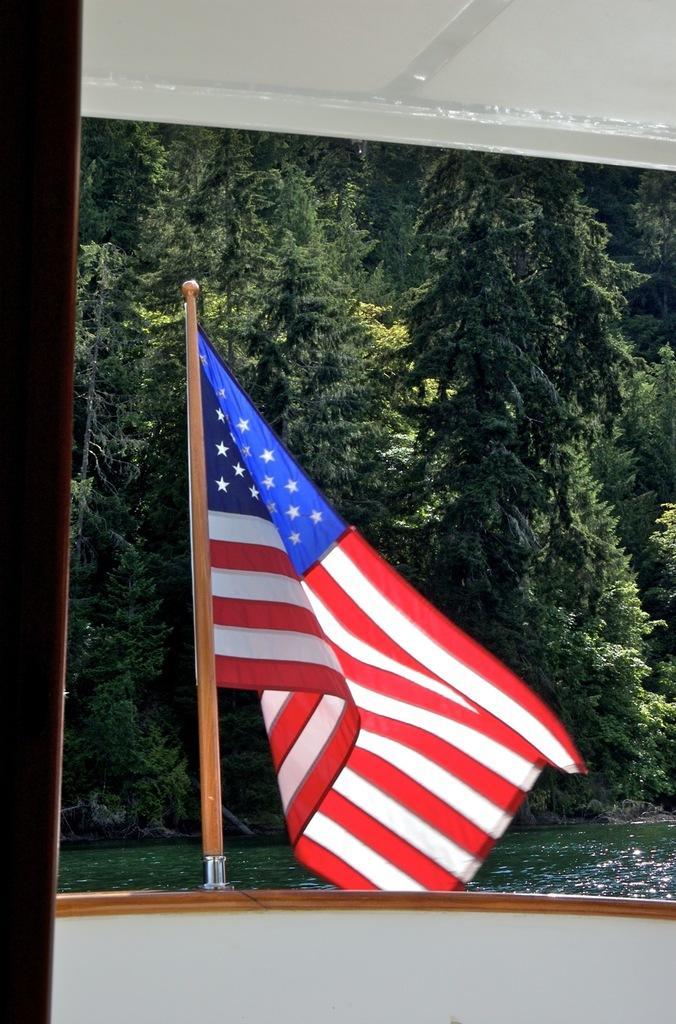How would you summarize this image in a sentence or two? In this image there is a boat on the water in that boat there is a flag, in the background there are trees. 